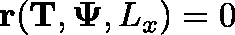<formula> <loc_0><loc_0><loc_500><loc_500>r ( T , \Psi , L _ { x } ) = 0</formula> 